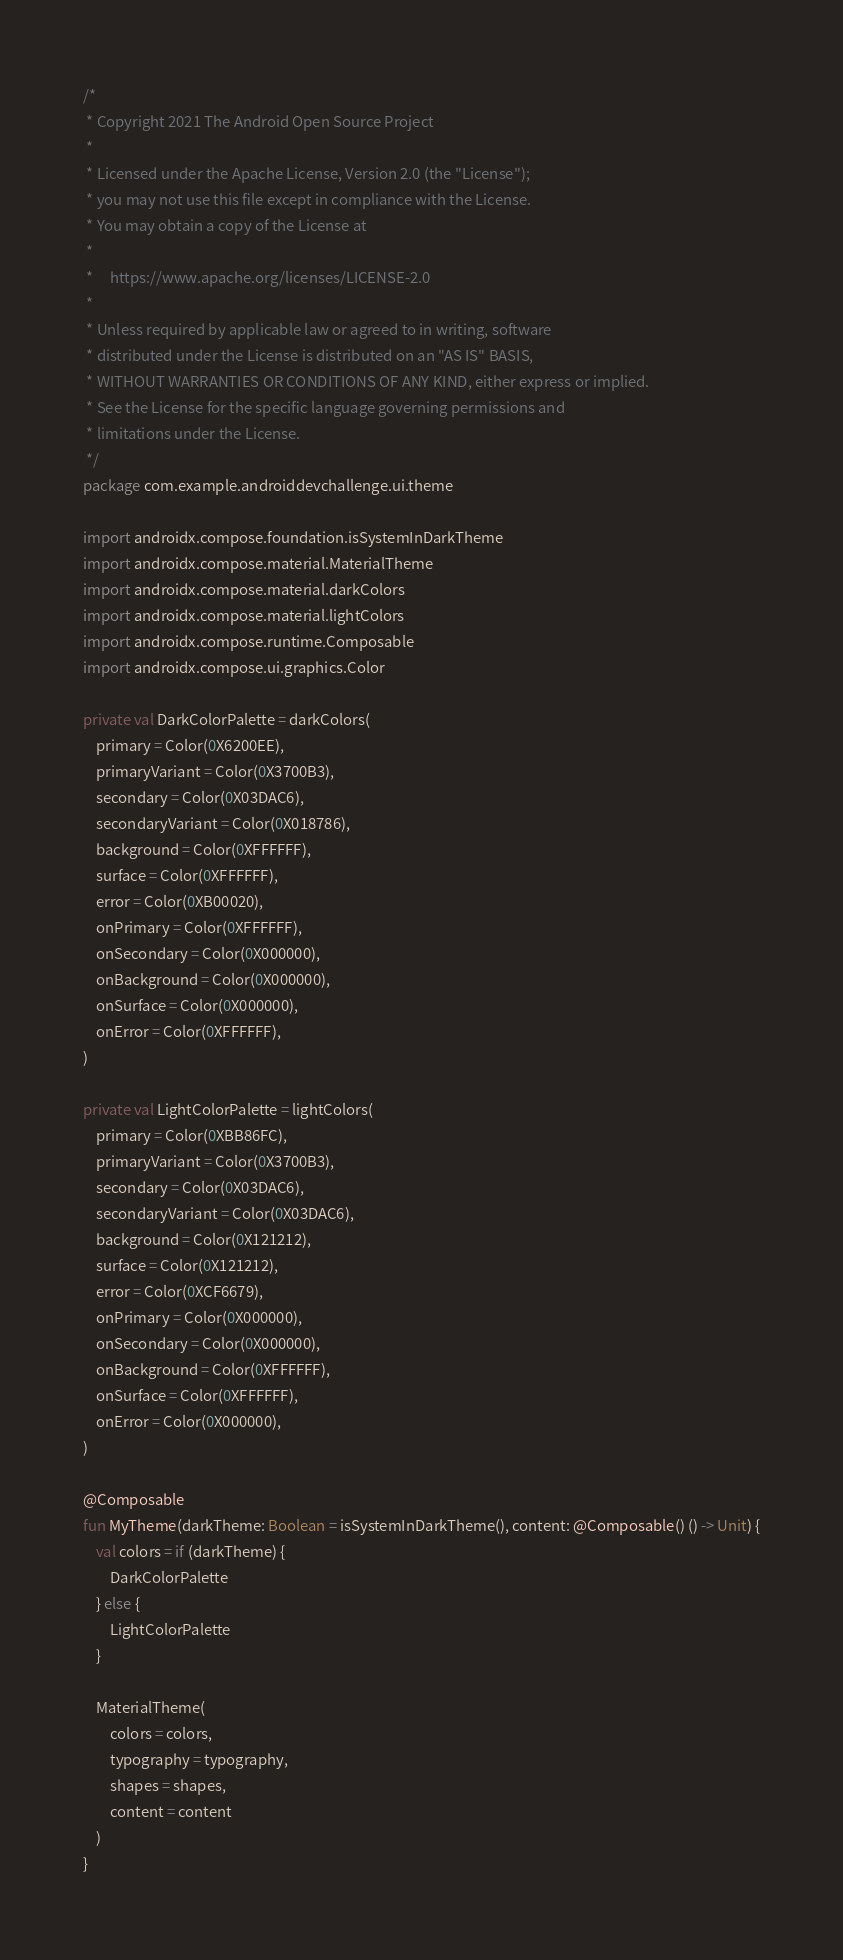Convert code to text. <code><loc_0><loc_0><loc_500><loc_500><_Kotlin_>/*
 * Copyright 2021 The Android Open Source Project
 *
 * Licensed under the Apache License, Version 2.0 (the "License");
 * you may not use this file except in compliance with the License.
 * You may obtain a copy of the License at
 *
 *     https://www.apache.org/licenses/LICENSE-2.0
 *
 * Unless required by applicable law or agreed to in writing, software
 * distributed under the License is distributed on an "AS IS" BASIS,
 * WITHOUT WARRANTIES OR CONDITIONS OF ANY KIND, either express or implied.
 * See the License for the specific language governing permissions and
 * limitations under the License.
 */
package com.example.androiddevchallenge.ui.theme

import androidx.compose.foundation.isSystemInDarkTheme
import androidx.compose.material.MaterialTheme
import androidx.compose.material.darkColors
import androidx.compose.material.lightColors
import androidx.compose.runtime.Composable
import androidx.compose.ui.graphics.Color

private val DarkColorPalette = darkColors(
    primary = Color(0X6200EE),
    primaryVariant = Color(0X3700B3),
    secondary = Color(0X03DAC6),
    secondaryVariant = Color(0X018786),
    background = Color(0XFFFFFF),
    surface = Color(0XFFFFFF),
    error = Color(0XB00020),
    onPrimary = Color(0XFFFFFF),
    onSecondary = Color(0X000000),
    onBackground = Color(0X000000),
    onSurface = Color(0X000000),
    onError = Color(0XFFFFFF),
)

private val LightColorPalette = lightColors(
    primary = Color(0XBB86FC),
    primaryVariant = Color(0X3700B3),
    secondary = Color(0X03DAC6),
    secondaryVariant = Color(0X03DAC6),
    background = Color(0X121212),
    surface = Color(0X121212),
    error = Color(0XCF6679),
    onPrimary = Color(0X000000),
    onSecondary = Color(0X000000),
    onBackground = Color(0XFFFFFF),
    onSurface = Color(0XFFFFFF),
    onError = Color(0X000000),
)

@Composable
fun MyTheme(darkTheme: Boolean = isSystemInDarkTheme(), content: @Composable() () -> Unit) {
    val colors = if (darkTheme) {
        DarkColorPalette
    } else {
        LightColorPalette
    }

    MaterialTheme(
        colors = colors,
        typography = typography,
        shapes = shapes,
        content = content
    )
}
</code> 